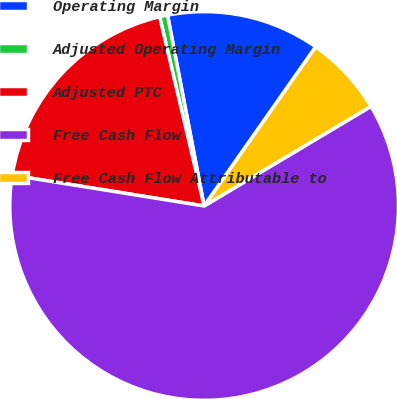Convert chart to OTSL. <chart><loc_0><loc_0><loc_500><loc_500><pie_chart><fcel>Operating Margin<fcel>Adjusted Operating Margin<fcel>Adjusted PTC<fcel>Free Cash Flow<fcel>Free Cash Flow Attributable to<nl><fcel>12.75%<fcel>0.66%<fcel>18.79%<fcel>61.1%<fcel>6.7%<nl></chart> 